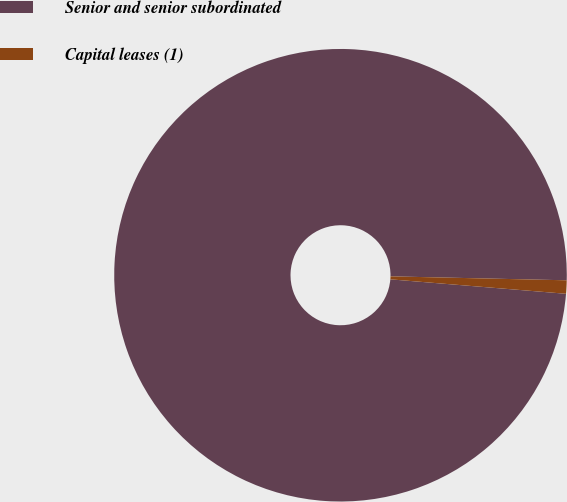<chart> <loc_0><loc_0><loc_500><loc_500><pie_chart><fcel>Senior and senior subordinated<fcel>Capital leases (1)<nl><fcel>99.05%<fcel>0.95%<nl></chart> 